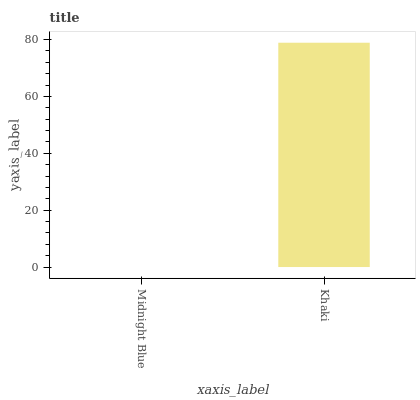Is Midnight Blue the minimum?
Answer yes or no. Yes. Is Khaki the maximum?
Answer yes or no. Yes. Is Khaki the minimum?
Answer yes or no. No. Is Khaki greater than Midnight Blue?
Answer yes or no. Yes. Is Midnight Blue less than Khaki?
Answer yes or no. Yes. Is Midnight Blue greater than Khaki?
Answer yes or no. No. Is Khaki less than Midnight Blue?
Answer yes or no. No. Is Khaki the high median?
Answer yes or no. Yes. Is Midnight Blue the low median?
Answer yes or no. Yes. Is Midnight Blue the high median?
Answer yes or no. No. Is Khaki the low median?
Answer yes or no. No. 